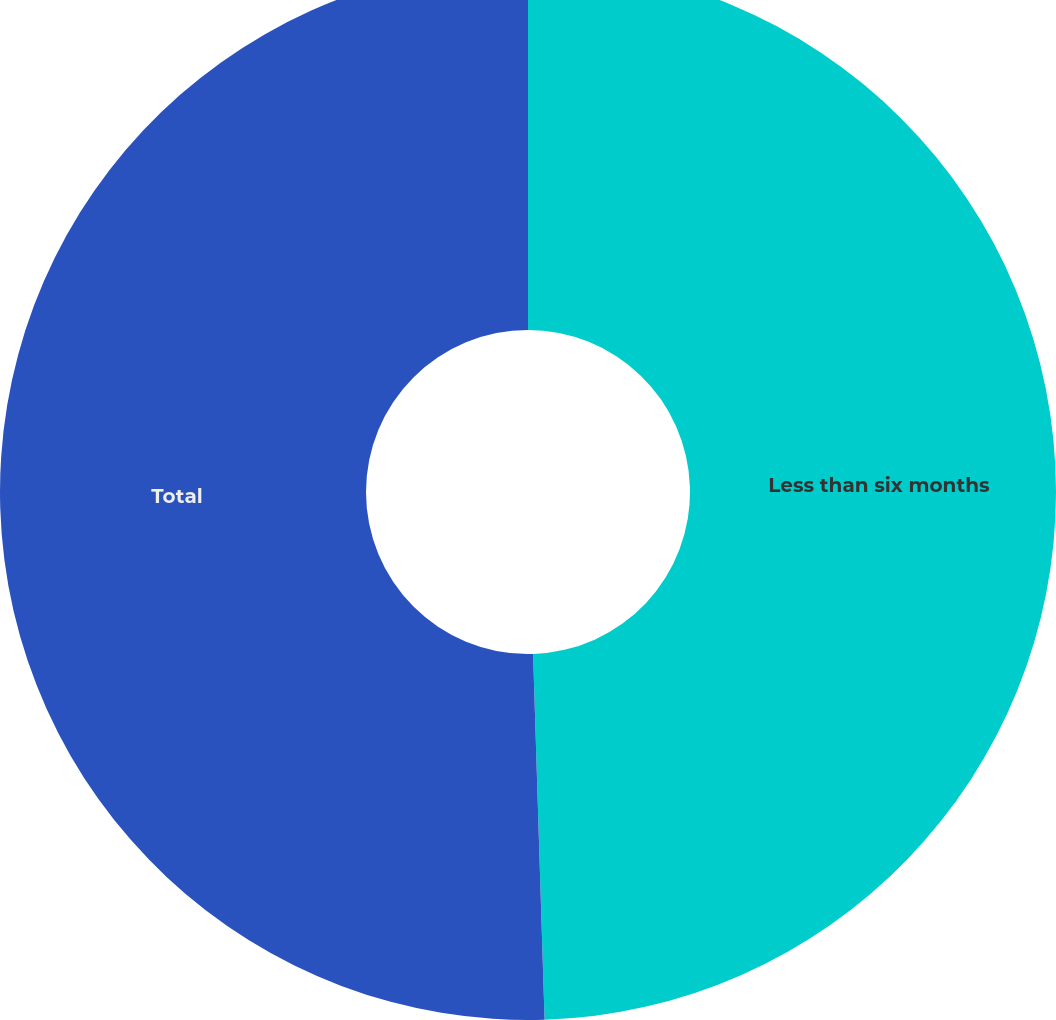Convert chart to OTSL. <chart><loc_0><loc_0><loc_500><loc_500><pie_chart><fcel>Less than six months<fcel>Total<nl><fcel>49.5%<fcel>50.5%<nl></chart> 